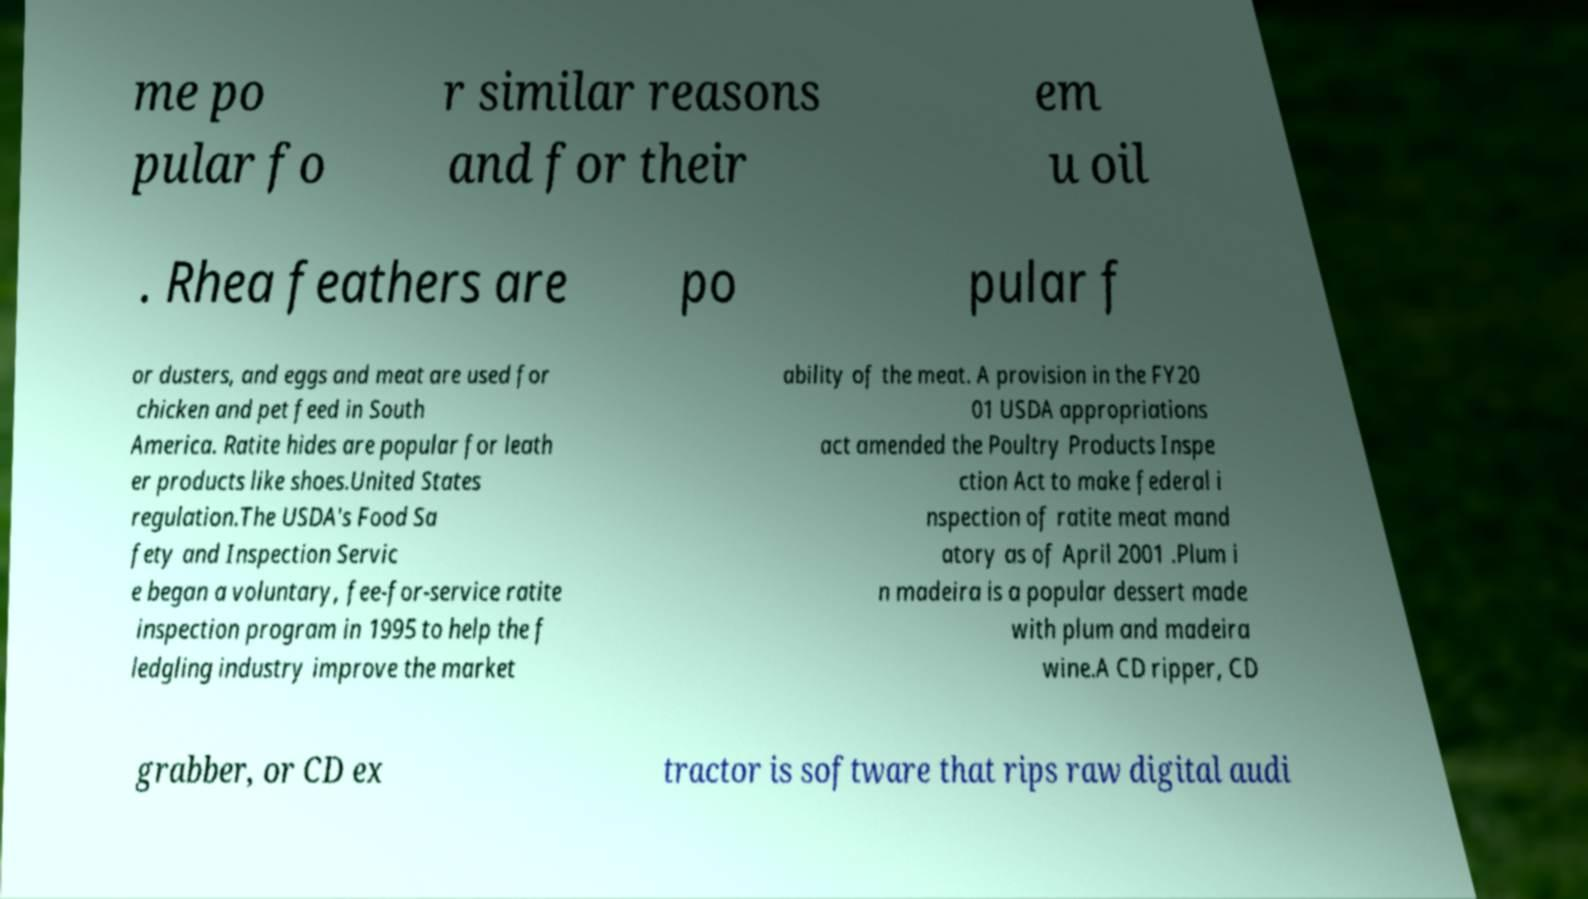What messages or text are displayed in this image? I need them in a readable, typed format. me po pular fo r similar reasons and for their em u oil . Rhea feathers are po pular f or dusters, and eggs and meat are used for chicken and pet feed in South America. Ratite hides are popular for leath er products like shoes.United States regulation.The USDA's Food Sa fety and Inspection Servic e began a voluntary, fee-for-service ratite inspection program in 1995 to help the f ledgling industry improve the market ability of the meat. A provision in the FY20 01 USDA appropriations act amended the Poultry Products Inspe ction Act to make federal i nspection of ratite meat mand atory as of April 2001 .Plum i n madeira is a popular dessert made with plum and madeira wine.A CD ripper, CD grabber, or CD ex tractor is software that rips raw digital audi 